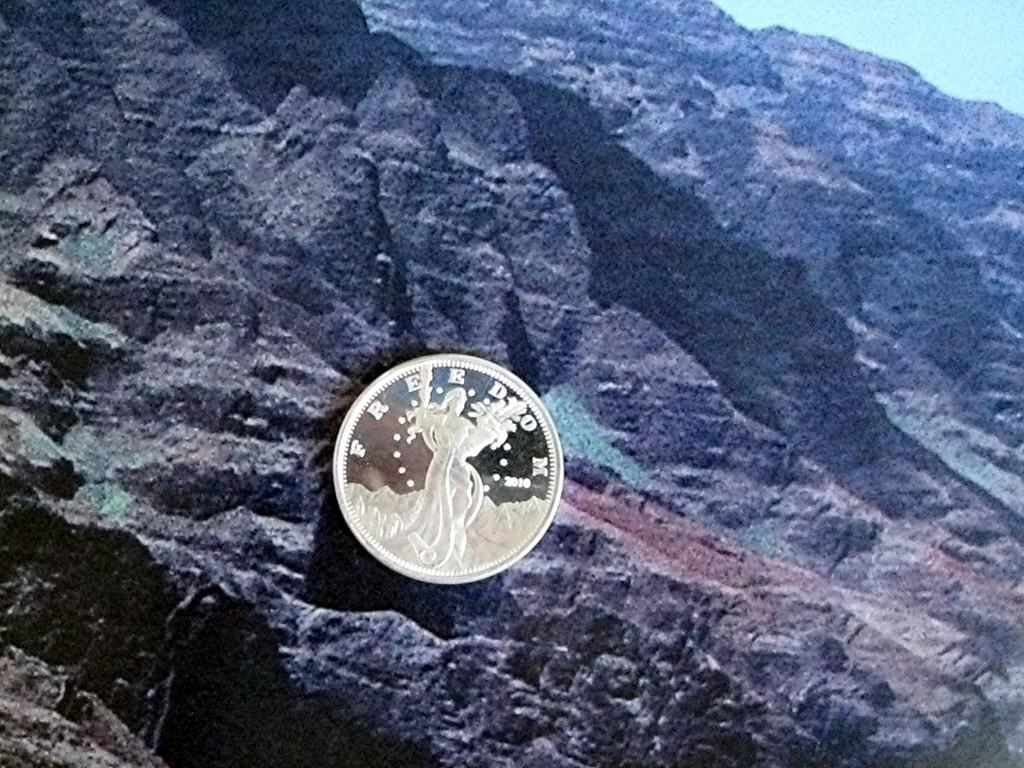<image>
Summarize the visual content of the image. Silver coin from 2010 saying freedom in front of a mountain background. 